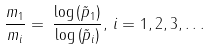Convert formula to latex. <formula><loc_0><loc_0><loc_500><loc_500>\frac { m _ { 1 } } { m _ { i } } = \, \frac { \log \left ( \tilde { p } _ { 1 } \right ) } { \log \left ( \tilde { p } _ { i } \right ) } , \, i = 1 , 2 , 3 , \dots</formula> 